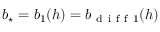Convert formula to latex. <formula><loc_0><loc_0><loc_500><loc_500>{ b _ { ^ { * } } } = b _ { 1 } ( h ) = b _ { d i f f 1 } ( h )</formula> 